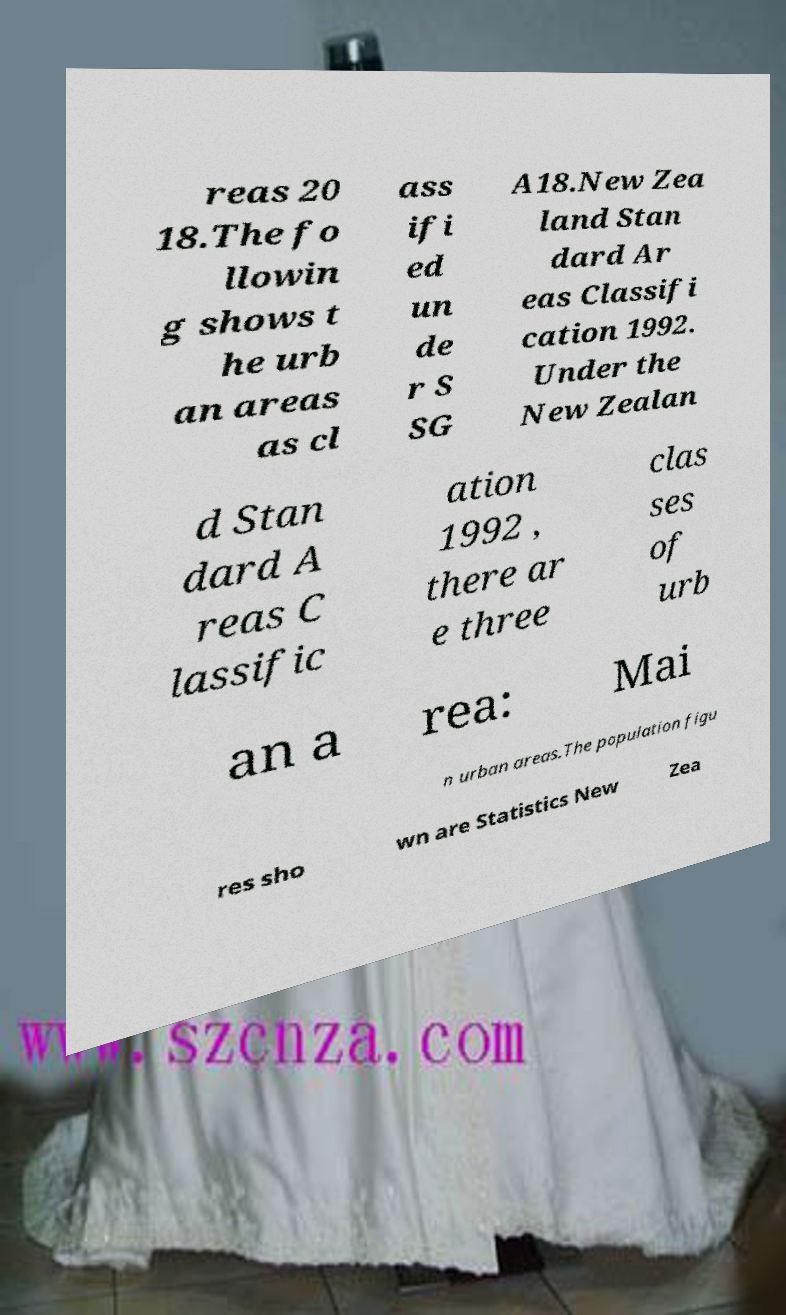What messages or text are displayed in this image? I need them in a readable, typed format. reas 20 18.The fo llowin g shows t he urb an areas as cl ass ifi ed un de r S SG A18.New Zea land Stan dard Ar eas Classifi cation 1992. Under the New Zealan d Stan dard A reas C lassific ation 1992 , there ar e three clas ses of urb an a rea: Mai n urban areas.The population figu res sho wn are Statistics New Zea 